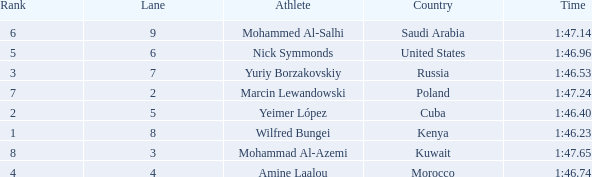65 and in lane 3 or bigger? None. 